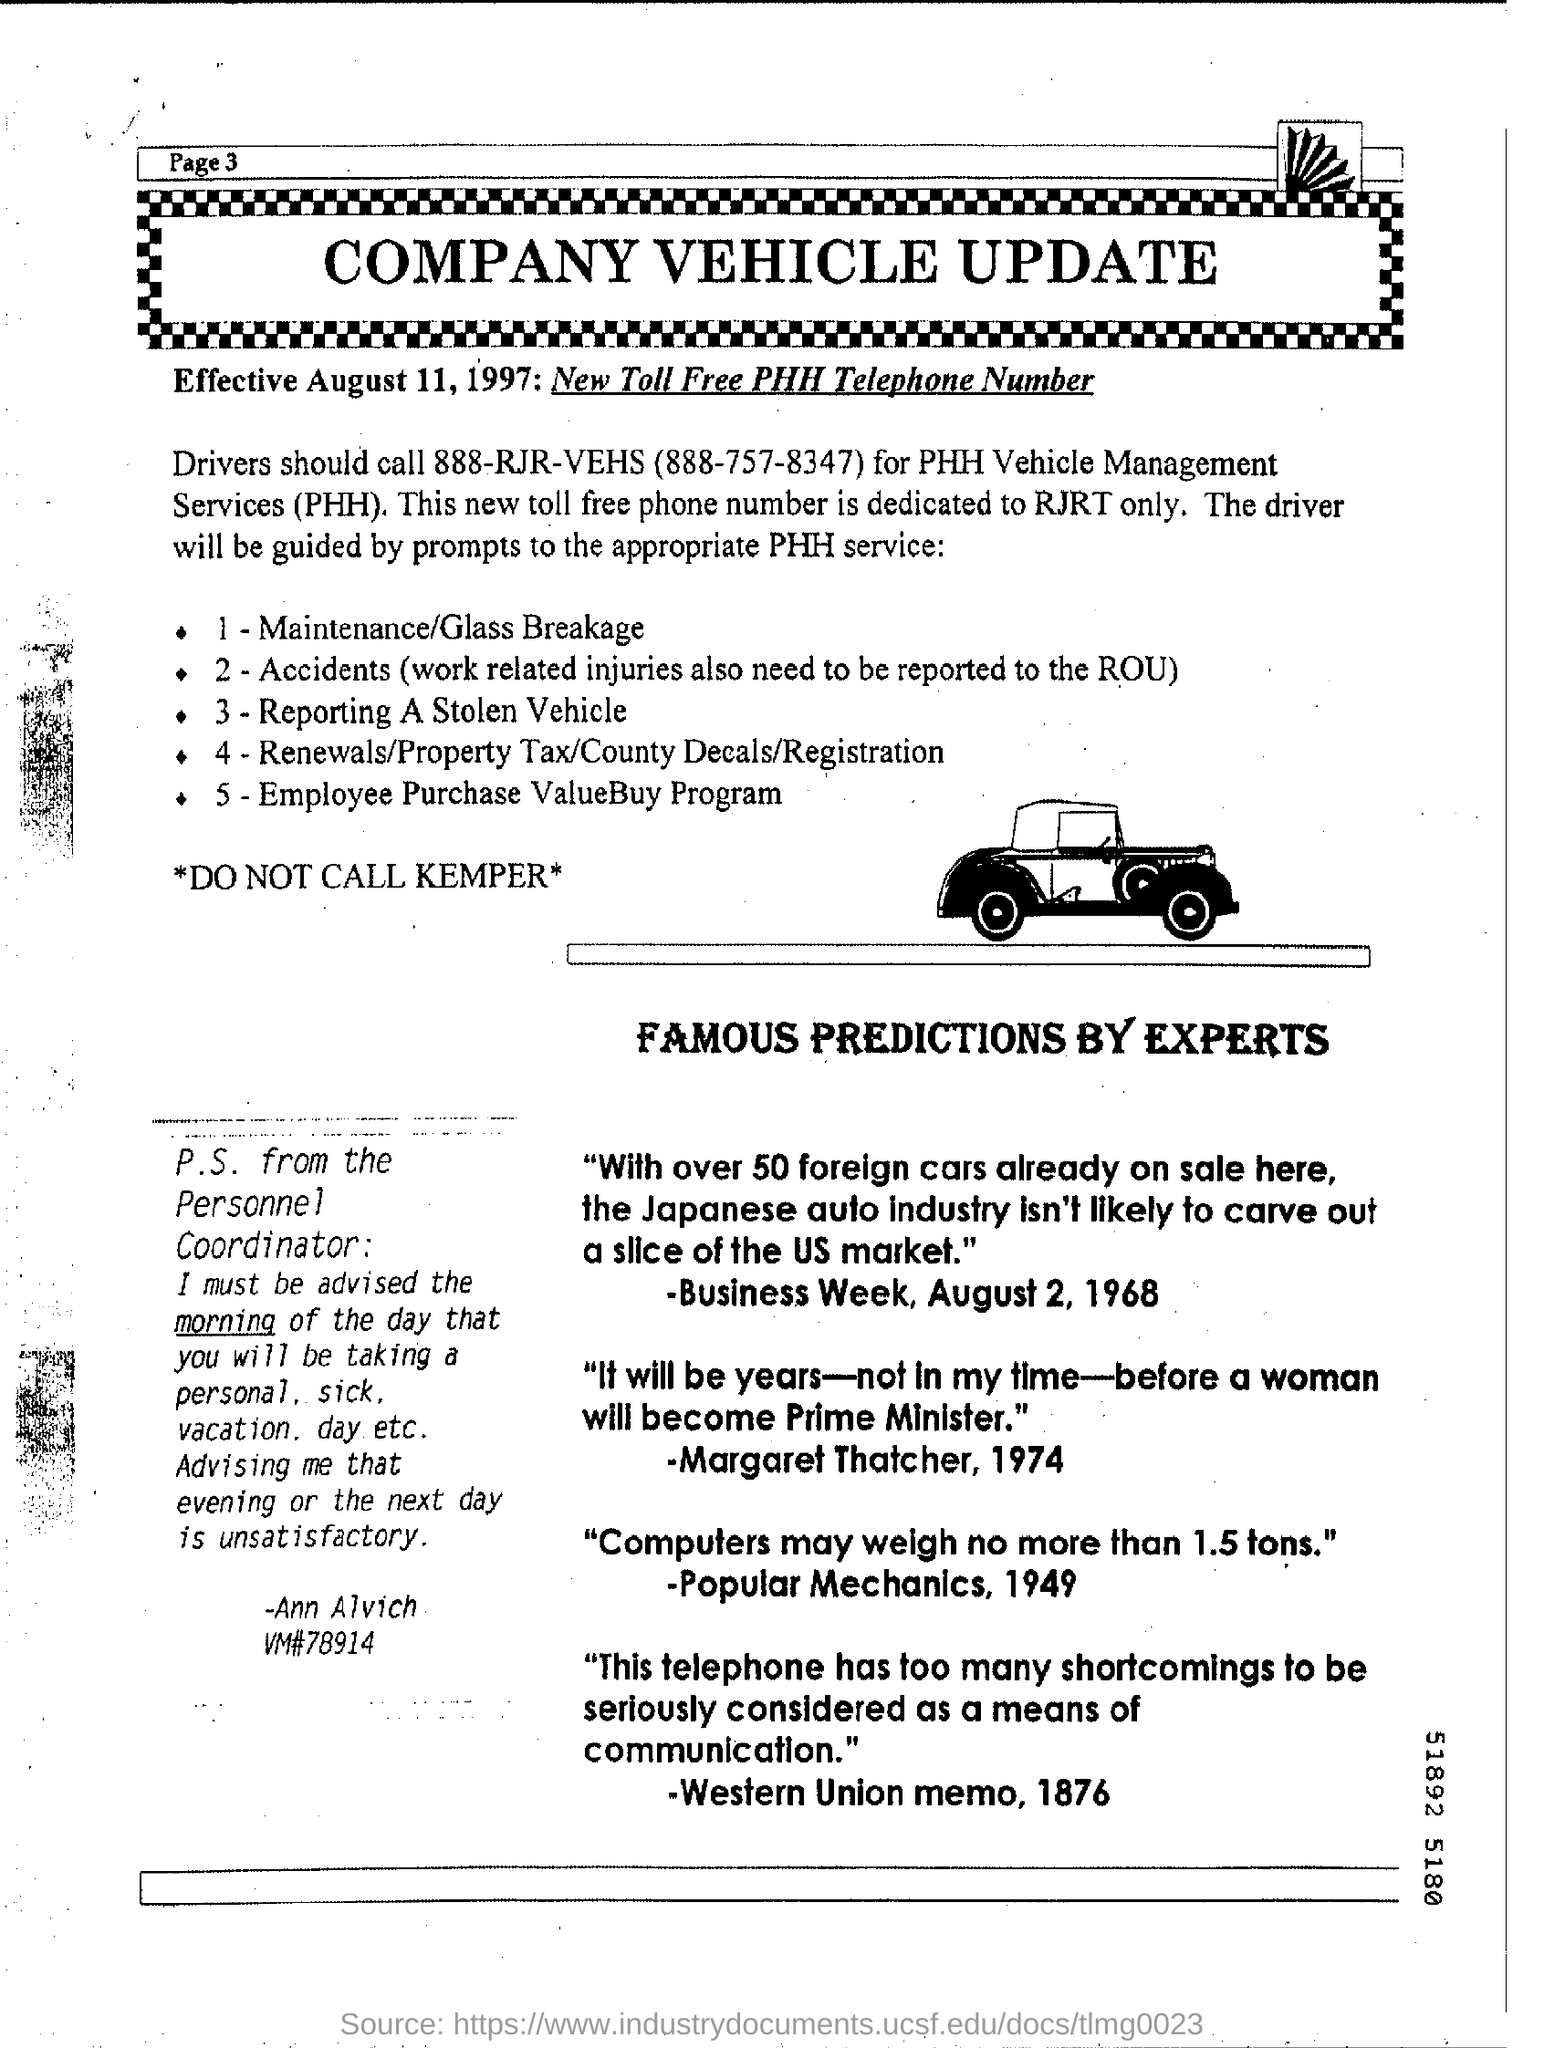Mention the page number at top left corner of the page ?
Give a very brief answer. Page 3. 